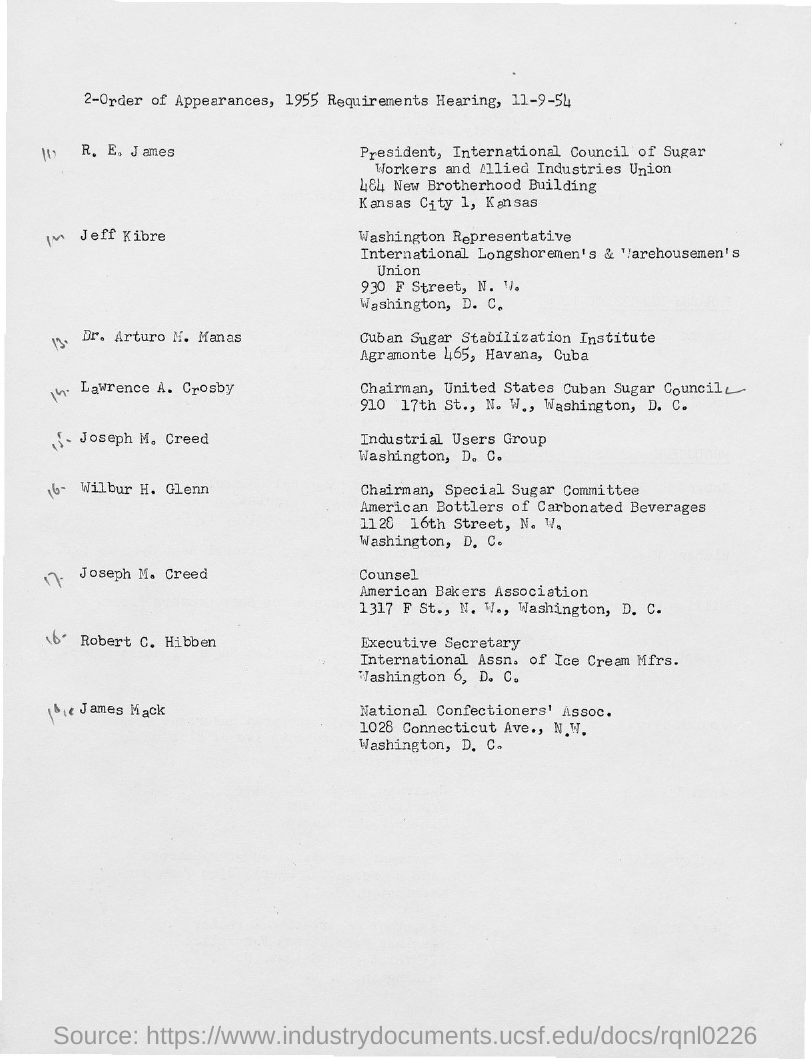Specify some key components in this picture. Lawrence A. Crosby is the chairman of the United States Cuban Sugar Council. The counsel of the American Bakers Association is Joseph M. Creed. The Executive Secretary of the International Association of Ice Cream Manufacturers is Robert C. Hibben. 